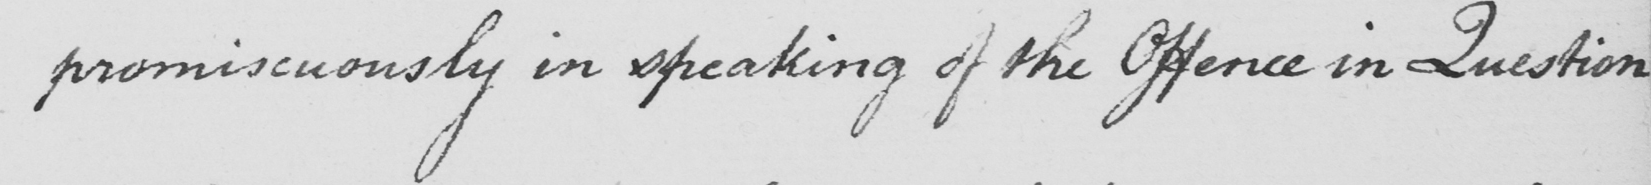Please transcribe the handwritten text in this image. promiscuously in speaking of the Offence in Question 